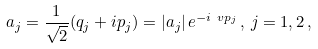Convert formula to latex. <formula><loc_0><loc_0><loc_500><loc_500>a _ { j } = \frac { 1 } { \sqrt { 2 } } ( q _ { j } + i p _ { j } ) = | a _ { j } | \, e ^ { - i \ v p _ { j } } \, , \, j = 1 , 2 \, ,</formula> 